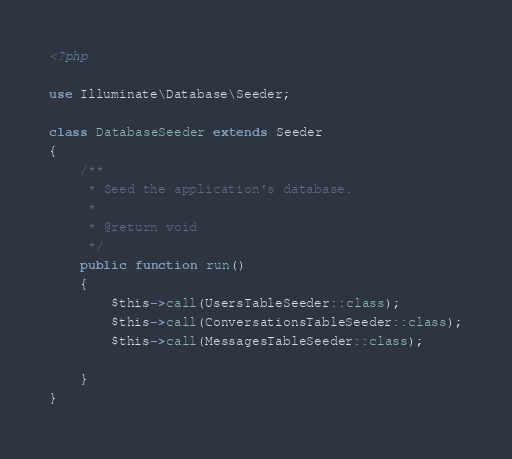Convert code to text. <code><loc_0><loc_0><loc_500><loc_500><_PHP_><?php

use Illuminate\Database\Seeder;

class DatabaseSeeder extends Seeder
{
    /**
     * Seed the application's database.
     *
     * @return void
     */
    public function run()
    {
        $this->call(UsersTableSeeder::class);
        $this->call(ConversationsTableSeeder::class);
        $this->call(MessagesTableSeeder::class);
        
    }
}
</code> 